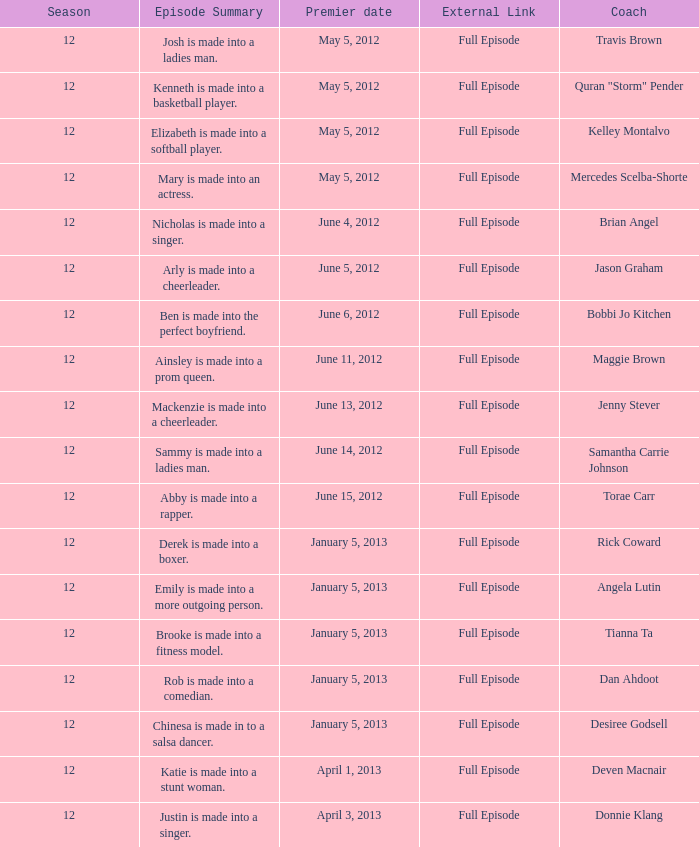Name the least episode for donnie klang 19.0. 